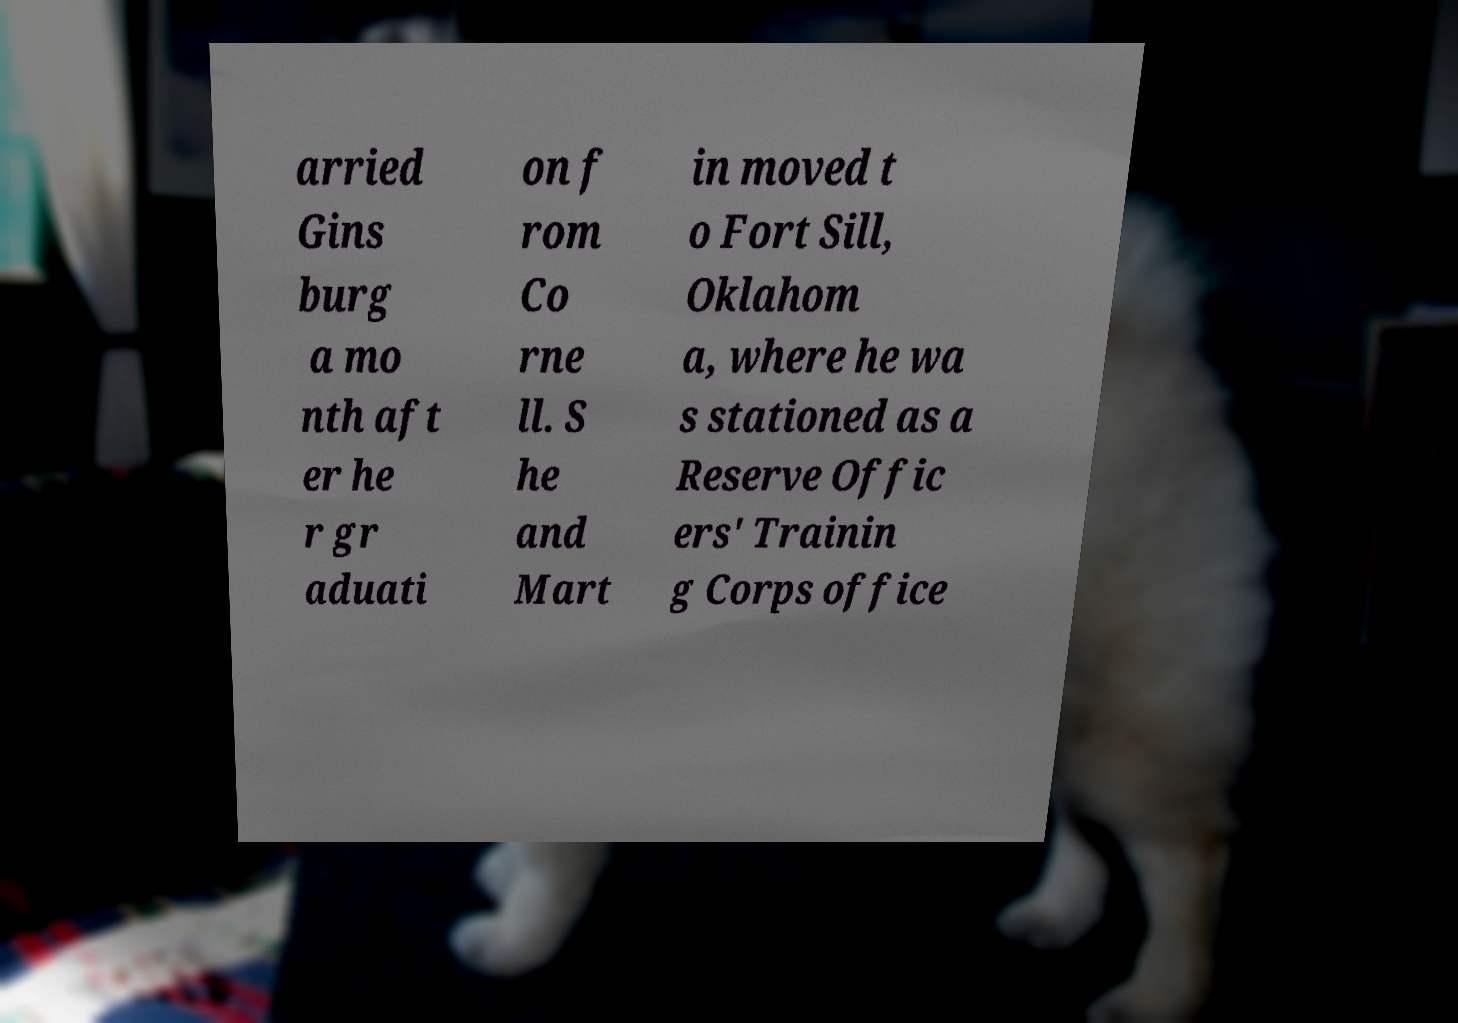Please read and relay the text visible in this image. What does it say? arried Gins burg a mo nth aft er he r gr aduati on f rom Co rne ll. S he and Mart in moved t o Fort Sill, Oklahom a, where he wa s stationed as a Reserve Offic ers' Trainin g Corps office 